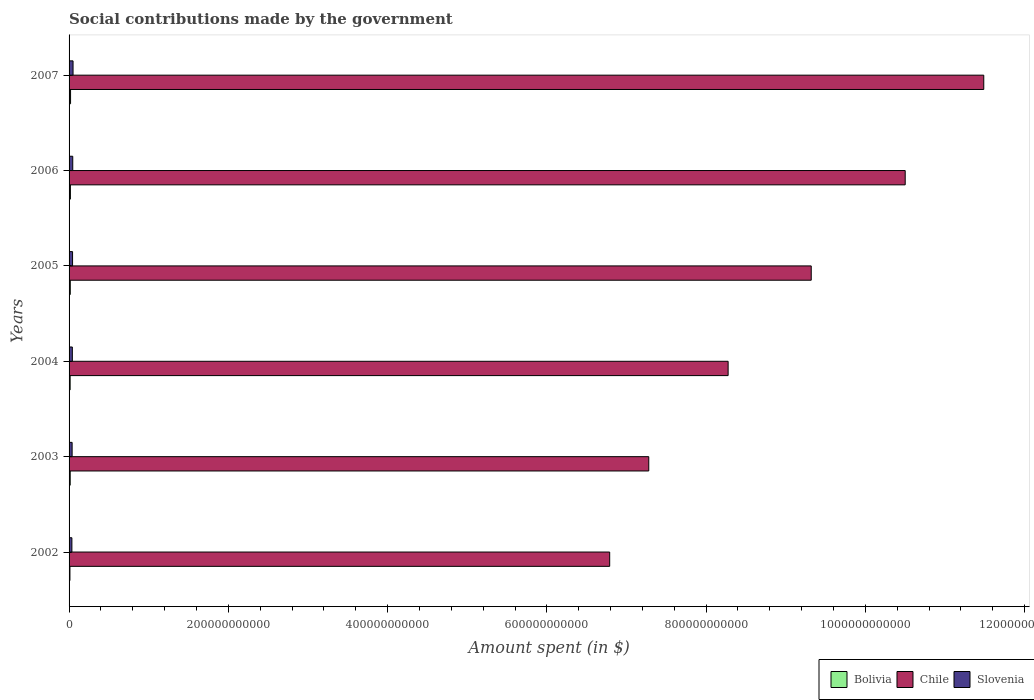How many different coloured bars are there?
Ensure brevity in your answer.  3. How many groups of bars are there?
Provide a short and direct response. 6. Are the number of bars on each tick of the Y-axis equal?
Keep it short and to the point. Yes. How many bars are there on the 5th tick from the top?
Provide a short and direct response. 3. How many bars are there on the 4th tick from the bottom?
Ensure brevity in your answer.  3. What is the amount spent on social contributions in Chile in 2007?
Give a very brief answer. 1.15e+12. Across all years, what is the maximum amount spent on social contributions in Bolivia?
Provide a succinct answer. 1.88e+09. Across all years, what is the minimum amount spent on social contributions in Slovenia?
Your answer should be compact. 3.54e+09. In which year was the amount spent on social contributions in Bolivia minimum?
Your answer should be compact. 2002. What is the total amount spent on social contributions in Bolivia in the graph?
Make the answer very short. 8.94e+09. What is the difference between the amount spent on social contributions in Bolivia in 2004 and that in 2007?
Provide a short and direct response. -5.41e+08. What is the difference between the amount spent on social contributions in Bolivia in 2005 and the amount spent on social contributions in Chile in 2003?
Ensure brevity in your answer.  -7.26e+11. What is the average amount spent on social contributions in Bolivia per year?
Ensure brevity in your answer.  1.49e+09. In the year 2004, what is the difference between the amount spent on social contributions in Slovenia and amount spent on social contributions in Chile?
Ensure brevity in your answer.  -8.24e+11. In how many years, is the amount spent on social contributions in Chile greater than 400000000000 $?
Your response must be concise. 6. What is the ratio of the amount spent on social contributions in Chile in 2002 to that in 2003?
Provide a succinct answer. 0.93. Is the amount spent on social contributions in Bolivia in 2002 less than that in 2005?
Provide a succinct answer. Yes. Is the difference between the amount spent on social contributions in Slovenia in 2002 and 2007 greater than the difference between the amount spent on social contributions in Chile in 2002 and 2007?
Make the answer very short. Yes. What is the difference between the highest and the second highest amount spent on social contributions in Chile?
Provide a succinct answer. 9.86e+1. What is the difference between the highest and the lowest amount spent on social contributions in Bolivia?
Provide a short and direct response. 7.95e+08. In how many years, is the amount spent on social contributions in Chile greater than the average amount spent on social contributions in Chile taken over all years?
Your answer should be very brief. 3. Is the sum of the amount spent on social contributions in Bolivia in 2002 and 2006 greater than the maximum amount spent on social contributions in Slovenia across all years?
Make the answer very short. No. What does the 3rd bar from the top in 2005 represents?
Give a very brief answer. Bolivia. What does the 2nd bar from the bottom in 2002 represents?
Keep it short and to the point. Chile. Is it the case that in every year, the sum of the amount spent on social contributions in Chile and amount spent on social contributions in Bolivia is greater than the amount spent on social contributions in Slovenia?
Give a very brief answer. Yes. How many years are there in the graph?
Offer a very short reply. 6. What is the difference between two consecutive major ticks on the X-axis?
Offer a very short reply. 2.00e+11. Are the values on the major ticks of X-axis written in scientific E-notation?
Provide a short and direct response. No. How are the legend labels stacked?
Your answer should be compact. Horizontal. What is the title of the graph?
Keep it short and to the point. Social contributions made by the government. What is the label or title of the X-axis?
Your answer should be very brief. Amount spent (in $). What is the Amount spent (in $) in Bolivia in 2002?
Your answer should be compact. 1.08e+09. What is the Amount spent (in $) in Chile in 2002?
Your answer should be very brief. 6.79e+11. What is the Amount spent (in $) of Slovenia in 2002?
Keep it short and to the point. 3.54e+09. What is the Amount spent (in $) in Bolivia in 2003?
Offer a very short reply. 1.43e+09. What is the Amount spent (in $) in Chile in 2003?
Your answer should be compact. 7.28e+11. What is the Amount spent (in $) of Slovenia in 2003?
Provide a short and direct response. 3.83e+09. What is the Amount spent (in $) of Bolivia in 2004?
Offer a very short reply. 1.34e+09. What is the Amount spent (in $) in Chile in 2004?
Offer a terse response. 8.28e+11. What is the Amount spent (in $) in Slovenia in 2004?
Keep it short and to the point. 4.11e+09. What is the Amount spent (in $) in Bolivia in 2005?
Keep it short and to the point. 1.52e+09. What is the Amount spent (in $) in Chile in 2005?
Ensure brevity in your answer.  9.32e+11. What is the Amount spent (in $) in Slovenia in 2005?
Ensure brevity in your answer.  4.38e+09. What is the Amount spent (in $) of Bolivia in 2006?
Your answer should be very brief. 1.68e+09. What is the Amount spent (in $) in Chile in 2006?
Make the answer very short. 1.05e+12. What is the Amount spent (in $) in Slovenia in 2006?
Offer a very short reply. 4.62e+09. What is the Amount spent (in $) of Bolivia in 2007?
Offer a very short reply. 1.88e+09. What is the Amount spent (in $) of Chile in 2007?
Provide a short and direct response. 1.15e+12. What is the Amount spent (in $) of Slovenia in 2007?
Your answer should be very brief. 5.00e+09. Across all years, what is the maximum Amount spent (in $) in Bolivia?
Your response must be concise. 1.88e+09. Across all years, what is the maximum Amount spent (in $) of Chile?
Provide a short and direct response. 1.15e+12. Across all years, what is the maximum Amount spent (in $) in Slovenia?
Provide a succinct answer. 5.00e+09. Across all years, what is the minimum Amount spent (in $) of Bolivia?
Keep it short and to the point. 1.08e+09. Across all years, what is the minimum Amount spent (in $) of Chile?
Your answer should be very brief. 6.79e+11. Across all years, what is the minimum Amount spent (in $) of Slovenia?
Give a very brief answer. 3.54e+09. What is the total Amount spent (in $) of Bolivia in the graph?
Ensure brevity in your answer.  8.94e+09. What is the total Amount spent (in $) in Chile in the graph?
Offer a very short reply. 5.37e+12. What is the total Amount spent (in $) of Slovenia in the graph?
Your answer should be compact. 2.55e+1. What is the difference between the Amount spent (in $) in Bolivia in 2002 and that in 2003?
Your answer should be compact. -3.46e+08. What is the difference between the Amount spent (in $) in Chile in 2002 and that in 2003?
Ensure brevity in your answer.  -4.91e+1. What is the difference between the Amount spent (in $) of Slovenia in 2002 and that in 2003?
Your answer should be very brief. -2.95e+08. What is the difference between the Amount spent (in $) in Bolivia in 2002 and that in 2004?
Offer a terse response. -2.54e+08. What is the difference between the Amount spent (in $) of Chile in 2002 and that in 2004?
Ensure brevity in your answer.  -1.49e+11. What is the difference between the Amount spent (in $) of Slovenia in 2002 and that in 2004?
Your response must be concise. -5.69e+08. What is the difference between the Amount spent (in $) of Bolivia in 2002 and that in 2005?
Make the answer very short. -4.39e+08. What is the difference between the Amount spent (in $) of Chile in 2002 and that in 2005?
Offer a very short reply. -2.53e+11. What is the difference between the Amount spent (in $) in Slovenia in 2002 and that in 2005?
Provide a succinct answer. -8.41e+08. What is the difference between the Amount spent (in $) of Bolivia in 2002 and that in 2006?
Give a very brief answer. -6.00e+08. What is the difference between the Amount spent (in $) in Chile in 2002 and that in 2006?
Your answer should be compact. -3.71e+11. What is the difference between the Amount spent (in $) in Slovenia in 2002 and that in 2006?
Provide a succinct answer. -1.08e+09. What is the difference between the Amount spent (in $) of Bolivia in 2002 and that in 2007?
Offer a very short reply. -7.95e+08. What is the difference between the Amount spent (in $) of Chile in 2002 and that in 2007?
Provide a succinct answer. -4.70e+11. What is the difference between the Amount spent (in $) in Slovenia in 2002 and that in 2007?
Make the answer very short. -1.46e+09. What is the difference between the Amount spent (in $) of Bolivia in 2003 and that in 2004?
Your answer should be compact. 9.22e+07. What is the difference between the Amount spent (in $) of Chile in 2003 and that in 2004?
Ensure brevity in your answer.  -9.96e+1. What is the difference between the Amount spent (in $) in Slovenia in 2003 and that in 2004?
Give a very brief answer. -2.74e+08. What is the difference between the Amount spent (in $) of Bolivia in 2003 and that in 2005?
Make the answer very short. -9.23e+07. What is the difference between the Amount spent (in $) in Chile in 2003 and that in 2005?
Make the answer very short. -2.04e+11. What is the difference between the Amount spent (in $) in Slovenia in 2003 and that in 2005?
Make the answer very short. -5.46e+08. What is the difference between the Amount spent (in $) in Bolivia in 2003 and that in 2006?
Provide a short and direct response. -2.54e+08. What is the difference between the Amount spent (in $) of Chile in 2003 and that in 2006?
Your answer should be very brief. -3.22e+11. What is the difference between the Amount spent (in $) in Slovenia in 2003 and that in 2006?
Your answer should be very brief. -7.86e+08. What is the difference between the Amount spent (in $) of Bolivia in 2003 and that in 2007?
Keep it short and to the point. -4.49e+08. What is the difference between the Amount spent (in $) in Chile in 2003 and that in 2007?
Keep it short and to the point. -4.21e+11. What is the difference between the Amount spent (in $) in Slovenia in 2003 and that in 2007?
Ensure brevity in your answer.  -1.17e+09. What is the difference between the Amount spent (in $) in Bolivia in 2004 and that in 2005?
Provide a succinct answer. -1.84e+08. What is the difference between the Amount spent (in $) in Chile in 2004 and that in 2005?
Your response must be concise. -1.04e+11. What is the difference between the Amount spent (in $) in Slovenia in 2004 and that in 2005?
Ensure brevity in your answer.  -2.72e+08. What is the difference between the Amount spent (in $) in Bolivia in 2004 and that in 2006?
Give a very brief answer. -3.46e+08. What is the difference between the Amount spent (in $) of Chile in 2004 and that in 2006?
Provide a short and direct response. -2.22e+11. What is the difference between the Amount spent (in $) in Slovenia in 2004 and that in 2006?
Give a very brief answer. -5.12e+08. What is the difference between the Amount spent (in $) of Bolivia in 2004 and that in 2007?
Offer a very short reply. -5.41e+08. What is the difference between the Amount spent (in $) in Chile in 2004 and that in 2007?
Your answer should be compact. -3.21e+11. What is the difference between the Amount spent (in $) in Slovenia in 2004 and that in 2007?
Give a very brief answer. -8.94e+08. What is the difference between the Amount spent (in $) of Bolivia in 2005 and that in 2006?
Make the answer very short. -1.62e+08. What is the difference between the Amount spent (in $) of Chile in 2005 and that in 2006?
Your response must be concise. -1.18e+11. What is the difference between the Amount spent (in $) of Slovenia in 2005 and that in 2006?
Keep it short and to the point. -2.40e+08. What is the difference between the Amount spent (in $) of Bolivia in 2005 and that in 2007?
Provide a succinct answer. -3.57e+08. What is the difference between the Amount spent (in $) of Chile in 2005 and that in 2007?
Your answer should be very brief. -2.17e+11. What is the difference between the Amount spent (in $) in Slovenia in 2005 and that in 2007?
Keep it short and to the point. -6.22e+08. What is the difference between the Amount spent (in $) of Bolivia in 2006 and that in 2007?
Make the answer very short. -1.95e+08. What is the difference between the Amount spent (in $) in Chile in 2006 and that in 2007?
Make the answer very short. -9.86e+1. What is the difference between the Amount spent (in $) of Slovenia in 2006 and that in 2007?
Provide a short and direct response. -3.82e+08. What is the difference between the Amount spent (in $) of Bolivia in 2002 and the Amount spent (in $) of Chile in 2003?
Offer a very short reply. -7.27e+11. What is the difference between the Amount spent (in $) of Bolivia in 2002 and the Amount spent (in $) of Slovenia in 2003?
Keep it short and to the point. -2.75e+09. What is the difference between the Amount spent (in $) of Chile in 2002 and the Amount spent (in $) of Slovenia in 2003?
Provide a short and direct response. 6.75e+11. What is the difference between the Amount spent (in $) in Bolivia in 2002 and the Amount spent (in $) in Chile in 2004?
Keep it short and to the point. -8.27e+11. What is the difference between the Amount spent (in $) in Bolivia in 2002 and the Amount spent (in $) in Slovenia in 2004?
Offer a terse response. -3.02e+09. What is the difference between the Amount spent (in $) in Chile in 2002 and the Amount spent (in $) in Slovenia in 2004?
Give a very brief answer. 6.75e+11. What is the difference between the Amount spent (in $) of Bolivia in 2002 and the Amount spent (in $) of Chile in 2005?
Keep it short and to the point. -9.31e+11. What is the difference between the Amount spent (in $) in Bolivia in 2002 and the Amount spent (in $) in Slovenia in 2005?
Ensure brevity in your answer.  -3.30e+09. What is the difference between the Amount spent (in $) of Chile in 2002 and the Amount spent (in $) of Slovenia in 2005?
Your answer should be very brief. 6.75e+11. What is the difference between the Amount spent (in $) of Bolivia in 2002 and the Amount spent (in $) of Chile in 2006?
Keep it short and to the point. -1.05e+12. What is the difference between the Amount spent (in $) of Bolivia in 2002 and the Amount spent (in $) of Slovenia in 2006?
Provide a succinct answer. -3.54e+09. What is the difference between the Amount spent (in $) of Chile in 2002 and the Amount spent (in $) of Slovenia in 2006?
Offer a terse response. 6.74e+11. What is the difference between the Amount spent (in $) in Bolivia in 2002 and the Amount spent (in $) in Chile in 2007?
Ensure brevity in your answer.  -1.15e+12. What is the difference between the Amount spent (in $) of Bolivia in 2002 and the Amount spent (in $) of Slovenia in 2007?
Ensure brevity in your answer.  -3.92e+09. What is the difference between the Amount spent (in $) of Chile in 2002 and the Amount spent (in $) of Slovenia in 2007?
Your answer should be compact. 6.74e+11. What is the difference between the Amount spent (in $) in Bolivia in 2003 and the Amount spent (in $) in Chile in 2004?
Ensure brevity in your answer.  -8.26e+11. What is the difference between the Amount spent (in $) in Bolivia in 2003 and the Amount spent (in $) in Slovenia in 2004?
Give a very brief answer. -2.68e+09. What is the difference between the Amount spent (in $) of Chile in 2003 and the Amount spent (in $) of Slovenia in 2004?
Ensure brevity in your answer.  7.24e+11. What is the difference between the Amount spent (in $) of Bolivia in 2003 and the Amount spent (in $) of Chile in 2005?
Offer a terse response. -9.31e+11. What is the difference between the Amount spent (in $) of Bolivia in 2003 and the Amount spent (in $) of Slovenia in 2005?
Provide a short and direct response. -2.95e+09. What is the difference between the Amount spent (in $) of Chile in 2003 and the Amount spent (in $) of Slovenia in 2005?
Your answer should be compact. 7.24e+11. What is the difference between the Amount spent (in $) of Bolivia in 2003 and the Amount spent (in $) of Chile in 2006?
Make the answer very short. -1.05e+12. What is the difference between the Amount spent (in $) of Bolivia in 2003 and the Amount spent (in $) of Slovenia in 2006?
Offer a very short reply. -3.19e+09. What is the difference between the Amount spent (in $) in Chile in 2003 and the Amount spent (in $) in Slovenia in 2006?
Give a very brief answer. 7.23e+11. What is the difference between the Amount spent (in $) in Bolivia in 2003 and the Amount spent (in $) in Chile in 2007?
Offer a terse response. -1.15e+12. What is the difference between the Amount spent (in $) of Bolivia in 2003 and the Amount spent (in $) of Slovenia in 2007?
Your response must be concise. -3.57e+09. What is the difference between the Amount spent (in $) in Chile in 2003 and the Amount spent (in $) in Slovenia in 2007?
Provide a short and direct response. 7.23e+11. What is the difference between the Amount spent (in $) in Bolivia in 2004 and the Amount spent (in $) in Chile in 2005?
Keep it short and to the point. -9.31e+11. What is the difference between the Amount spent (in $) in Bolivia in 2004 and the Amount spent (in $) in Slovenia in 2005?
Offer a very short reply. -3.04e+09. What is the difference between the Amount spent (in $) in Chile in 2004 and the Amount spent (in $) in Slovenia in 2005?
Your answer should be compact. 8.23e+11. What is the difference between the Amount spent (in $) in Bolivia in 2004 and the Amount spent (in $) in Chile in 2006?
Your answer should be compact. -1.05e+12. What is the difference between the Amount spent (in $) of Bolivia in 2004 and the Amount spent (in $) of Slovenia in 2006?
Provide a succinct answer. -3.28e+09. What is the difference between the Amount spent (in $) in Chile in 2004 and the Amount spent (in $) in Slovenia in 2006?
Offer a very short reply. 8.23e+11. What is the difference between the Amount spent (in $) of Bolivia in 2004 and the Amount spent (in $) of Chile in 2007?
Your answer should be very brief. -1.15e+12. What is the difference between the Amount spent (in $) in Bolivia in 2004 and the Amount spent (in $) in Slovenia in 2007?
Make the answer very short. -3.66e+09. What is the difference between the Amount spent (in $) of Chile in 2004 and the Amount spent (in $) of Slovenia in 2007?
Your answer should be compact. 8.23e+11. What is the difference between the Amount spent (in $) of Bolivia in 2005 and the Amount spent (in $) of Chile in 2006?
Offer a very short reply. -1.05e+12. What is the difference between the Amount spent (in $) of Bolivia in 2005 and the Amount spent (in $) of Slovenia in 2006?
Give a very brief answer. -3.10e+09. What is the difference between the Amount spent (in $) of Chile in 2005 and the Amount spent (in $) of Slovenia in 2006?
Ensure brevity in your answer.  9.27e+11. What is the difference between the Amount spent (in $) in Bolivia in 2005 and the Amount spent (in $) in Chile in 2007?
Make the answer very short. -1.15e+12. What is the difference between the Amount spent (in $) in Bolivia in 2005 and the Amount spent (in $) in Slovenia in 2007?
Ensure brevity in your answer.  -3.48e+09. What is the difference between the Amount spent (in $) in Chile in 2005 and the Amount spent (in $) in Slovenia in 2007?
Ensure brevity in your answer.  9.27e+11. What is the difference between the Amount spent (in $) of Bolivia in 2006 and the Amount spent (in $) of Chile in 2007?
Your response must be concise. -1.15e+12. What is the difference between the Amount spent (in $) of Bolivia in 2006 and the Amount spent (in $) of Slovenia in 2007?
Make the answer very short. -3.32e+09. What is the difference between the Amount spent (in $) in Chile in 2006 and the Amount spent (in $) in Slovenia in 2007?
Provide a succinct answer. 1.04e+12. What is the average Amount spent (in $) of Bolivia per year?
Ensure brevity in your answer.  1.49e+09. What is the average Amount spent (in $) of Chile per year?
Ensure brevity in your answer.  8.94e+11. What is the average Amount spent (in $) in Slovenia per year?
Provide a succinct answer. 4.25e+09. In the year 2002, what is the difference between the Amount spent (in $) of Bolivia and Amount spent (in $) of Chile?
Make the answer very short. -6.78e+11. In the year 2002, what is the difference between the Amount spent (in $) in Bolivia and Amount spent (in $) in Slovenia?
Keep it short and to the point. -2.45e+09. In the year 2002, what is the difference between the Amount spent (in $) in Chile and Amount spent (in $) in Slovenia?
Offer a terse response. 6.75e+11. In the year 2003, what is the difference between the Amount spent (in $) in Bolivia and Amount spent (in $) in Chile?
Your answer should be compact. -7.27e+11. In the year 2003, what is the difference between the Amount spent (in $) of Bolivia and Amount spent (in $) of Slovenia?
Ensure brevity in your answer.  -2.40e+09. In the year 2003, what is the difference between the Amount spent (in $) in Chile and Amount spent (in $) in Slovenia?
Give a very brief answer. 7.24e+11. In the year 2004, what is the difference between the Amount spent (in $) of Bolivia and Amount spent (in $) of Chile?
Keep it short and to the point. -8.26e+11. In the year 2004, what is the difference between the Amount spent (in $) in Bolivia and Amount spent (in $) in Slovenia?
Your response must be concise. -2.77e+09. In the year 2004, what is the difference between the Amount spent (in $) of Chile and Amount spent (in $) of Slovenia?
Your answer should be very brief. 8.24e+11. In the year 2005, what is the difference between the Amount spent (in $) in Bolivia and Amount spent (in $) in Chile?
Offer a very short reply. -9.30e+11. In the year 2005, what is the difference between the Amount spent (in $) of Bolivia and Amount spent (in $) of Slovenia?
Keep it short and to the point. -2.86e+09. In the year 2005, what is the difference between the Amount spent (in $) in Chile and Amount spent (in $) in Slovenia?
Provide a short and direct response. 9.28e+11. In the year 2006, what is the difference between the Amount spent (in $) of Bolivia and Amount spent (in $) of Chile?
Offer a terse response. -1.05e+12. In the year 2006, what is the difference between the Amount spent (in $) of Bolivia and Amount spent (in $) of Slovenia?
Offer a very short reply. -2.94e+09. In the year 2006, what is the difference between the Amount spent (in $) in Chile and Amount spent (in $) in Slovenia?
Your answer should be compact. 1.05e+12. In the year 2007, what is the difference between the Amount spent (in $) of Bolivia and Amount spent (in $) of Chile?
Keep it short and to the point. -1.15e+12. In the year 2007, what is the difference between the Amount spent (in $) of Bolivia and Amount spent (in $) of Slovenia?
Your answer should be compact. -3.12e+09. In the year 2007, what is the difference between the Amount spent (in $) of Chile and Amount spent (in $) of Slovenia?
Provide a succinct answer. 1.14e+12. What is the ratio of the Amount spent (in $) of Bolivia in 2002 to that in 2003?
Keep it short and to the point. 0.76. What is the ratio of the Amount spent (in $) of Chile in 2002 to that in 2003?
Ensure brevity in your answer.  0.93. What is the ratio of the Amount spent (in $) of Bolivia in 2002 to that in 2004?
Offer a terse response. 0.81. What is the ratio of the Amount spent (in $) in Chile in 2002 to that in 2004?
Give a very brief answer. 0.82. What is the ratio of the Amount spent (in $) of Slovenia in 2002 to that in 2004?
Make the answer very short. 0.86. What is the ratio of the Amount spent (in $) in Bolivia in 2002 to that in 2005?
Provide a succinct answer. 0.71. What is the ratio of the Amount spent (in $) in Chile in 2002 to that in 2005?
Keep it short and to the point. 0.73. What is the ratio of the Amount spent (in $) in Slovenia in 2002 to that in 2005?
Make the answer very short. 0.81. What is the ratio of the Amount spent (in $) in Bolivia in 2002 to that in 2006?
Your response must be concise. 0.64. What is the ratio of the Amount spent (in $) in Chile in 2002 to that in 2006?
Offer a terse response. 0.65. What is the ratio of the Amount spent (in $) of Slovenia in 2002 to that in 2006?
Your answer should be compact. 0.77. What is the ratio of the Amount spent (in $) of Bolivia in 2002 to that in 2007?
Make the answer very short. 0.58. What is the ratio of the Amount spent (in $) in Chile in 2002 to that in 2007?
Give a very brief answer. 0.59. What is the ratio of the Amount spent (in $) in Slovenia in 2002 to that in 2007?
Your response must be concise. 0.71. What is the ratio of the Amount spent (in $) of Bolivia in 2003 to that in 2004?
Your answer should be compact. 1.07. What is the ratio of the Amount spent (in $) in Chile in 2003 to that in 2004?
Offer a very short reply. 0.88. What is the ratio of the Amount spent (in $) in Slovenia in 2003 to that in 2004?
Offer a terse response. 0.93. What is the ratio of the Amount spent (in $) in Bolivia in 2003 to that in 2005?
Ensure brevity in your answer.  0.94. What is the ratio of the Amount spent (in $) in Chile in 2003 to that in 2005?
Provide a short and direct response. 0.78. What is the ratio of the Amount spent (in $) in Slovenia in 2003 to that in 2005?
Offer a very short reply. 0.88. What is the ratio of the Amount spent (in $) of Bolivia in 2003 to that in 2006?
Your response must be concise. 0.85. What is the ratio of the Amount spent (in $) in Chile in 2003 to that in 2006?
Keep it short and to the point. 0.69. What is the ratio of the Amount spent (in $) of Slovenia in 2003 to that in 2006?
Offer a very short reply. 0.83. What is the ratio of the Amount spent (in $) of Bolivia in 2003 to that in 2007?
Provide a succinct answer. 0.76. What is the ratio of the Amount spent (in $) in Chile in 2003 to that in 2007?
Make the answer very short. 0.63. What is the ratio of the Amount spent (in $) in Slovenia in 2003 to that in 2007?
Your answer should be compact. 0.77. What is the ratio of the Amount spent (in $) in Bolivia in 2004 to that in 2005?
Your answer should be compact. 0.88. What is the ratio of the Amount spent (in $) of Chile in 2004 to that in 2005?
Your answer should be compact. 0.89. What is the ratio of the Amount spent (in $) in Slovenia in 2004 to that in 2005?
Offer a very short reply. 0.94. What is the ratio of the Amount spent (in $) in Bolivia in 2004 to that in 2006?
Ensure brevity in your answer.  0.79. What is the ratio of the Amount spent (in $) of Chile in 2004 to that in 2006?
Provide a short and direct response. 0.79. What is the ratio of the Amount spent (in $) in Slovenia in 2004 to that in 2006?
Offer a terse response. 0.89. What is the ratio of the Amount spent (in $) in Bolivia in 2004 to that in 2007?
Your answer should be very brief. 0.71. What is the ratio of the Amount spent (in $) in Chile in 2004 to that in 2007?
Provide a short and direct response. 0.72. What is the ratio of the Amount spent (in $) of Slovenia in 2004 to that in 2007?
Your answer should be compact. 0.82. What is the ratio of the Amount spent (in $) of Bolivia in 2005 to that in 2006?
Your response must be concise. 0.9. What is the ratio of the Amount spent (in $) of Chile in 2005 to that in 2006?
Your answer should be very brief. 0.89. What is the ratio of the Amount spent (in $) of Slovenia in 2005 to that in 2006?
Offer a very short reply. 0.95. What is the ratio of the Amount spent (in $) of Bolivia in 2005 to that in 2007?
Offer a very short reply. 0.81. What is the ratio of the Amount spent (in $) in Chile in 2005 to that in 2007?
Provide a succinct answer. 0.81. What is the ratio of the Amount spent (in $) in Slovenia in 2005 to that in 2007?
Keep it short and to the point. 0.88. What is the ratio of the Amount spent (in $) of Bolivia in 2006 to that in 2007?
Your response must be concise. 0.9. What is the ratio of the Amount spent (in $) of Chile in 2006 to that in 2007?
Give a very brief answer. 0.91. What is the ratio of the Amount spent (in $) in Slovenia in 2006 to that in 2007?
Make the answer very short. 0.92. What is the difference between the highest and the second highest Amount spent (in $) in Bolivia?
Provide a succinct answer. 1.95e+08. What is the difference between the highest and the second highest Amount spent (in $) of Chile?
Your answer should be very brief. 9.86e+1. What is the difference between the highest and the second highest Amount spent (in $) of Slovenia?
Provide a succinct answer. 3.82e+08. What is the difference between the highest and the lowest Amount spent (in $) of Bolivia?
Make the answer very short. 7.95e+08. What is the difference between the highest and the lowest Amount spent (in $) in Chile?
Your answer should be very brief. 4.70e+11. What is the difference between the highest and the lowest Amount spent (in $) of Slovenia?
Provide a succinct answer. 1.46e+09. 